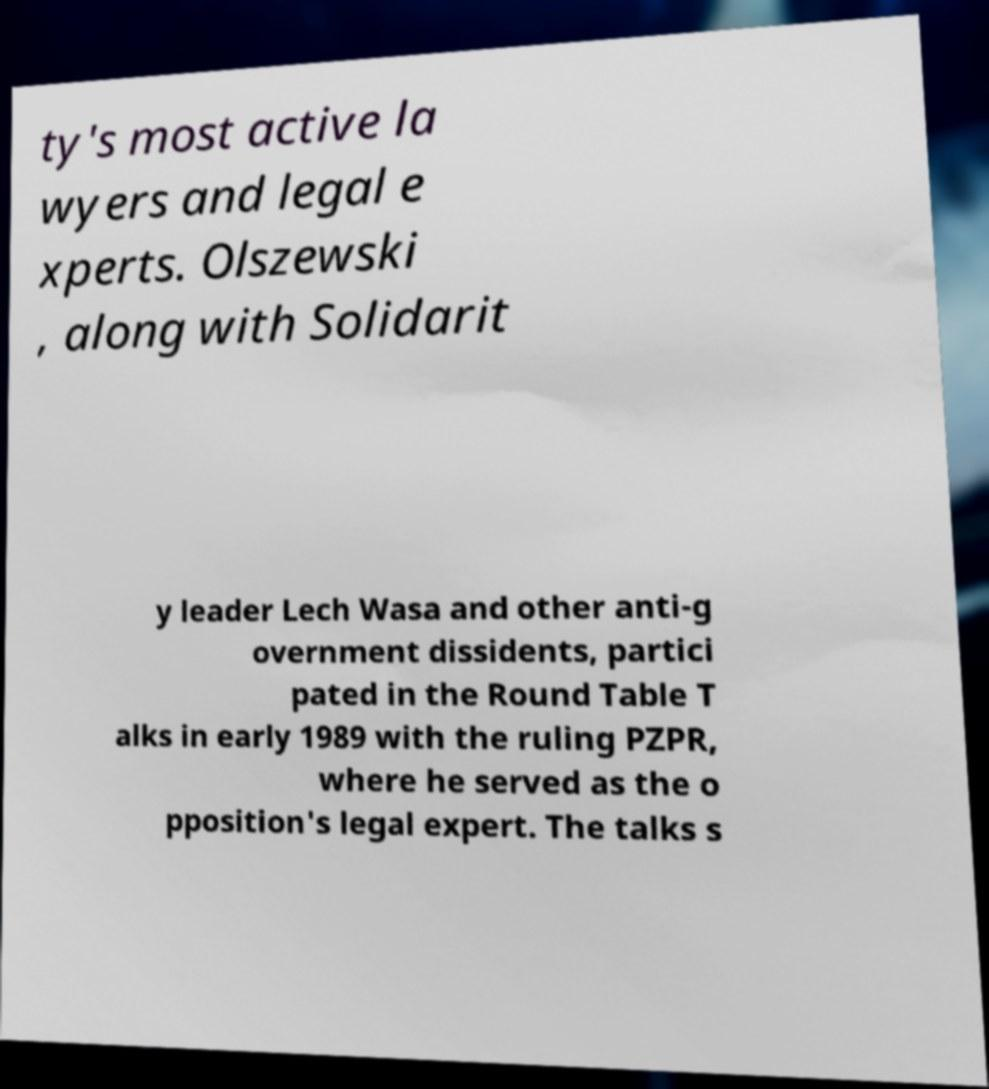There's text embedded in this image that I need extracted. Can you transcribe it verbatim? ty's most active la wyers and legal e xperts. Olszewski , along with Solidarit y leader Lech Wasa and other anti-g overnment dissidents, partici pated in the Round Table T alks in early 1989 with the ruling PZPR, where he served as the o pposition's legal expert. The talks s 